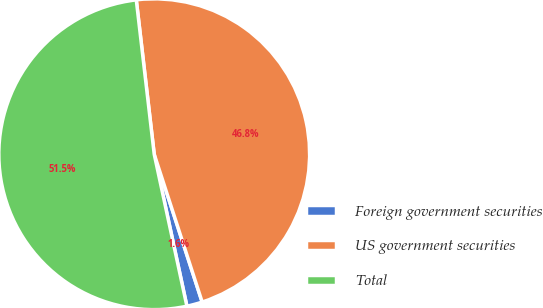<chart> <loc_0><loc_0><loc_500><loc_500><pie_chart><fcel>Foreign government securities<fcel>US government securities<fcel>Total<nl><fcel>1.62%<fcel>46.85%<fcel>51.53%<nl></chart> 